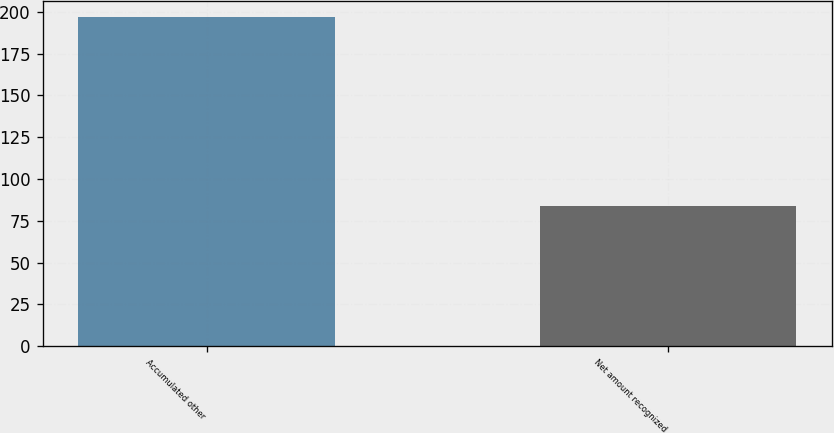<chart> <loc_0><loc_0><loc_500><loc_500><bar_chart><fcel>Accumulated other<fcel>Net amount recognized<nl><fcel>196.8<fcel>84.1<nl></chart> 